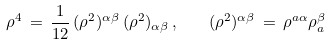Convert formula to latex. <formula><loc_0><loc_0><loc_500><loc_500>\rho ^ { 4 } \, = \, \frac { 1 } { 1 2 } \, ( \rho ^ { 2 } ) ^ { \alpha \beta } \, ( \rho ^ { 2 } ) _ { \alpha \beta } \, , \quad ( \rho ^ { 2 } ) ^ { \alpha \beta } \, = \, \rho ^ { a \alpha } \rho _ { a } ^ { \beta }</formula> 